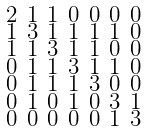<formula> <loc_0><loc_0><loc_500><loc_500>\begin{smallmatrix} 2 & 1 & 1 & 0 & 0 & 0 & 0 \\ 1 & 3 & 1 & 1 & 1 & 1 & 0 \\ 1 & 1 & 3 & 1 & 1 & 0 & 0 \\ 0 & 1 & 1 & 3 & 1 & 1 & 0 \\ 0 & 1 & 1 & 1 & 3 & 0 & 0 \\ 0 & 1 & 0 & 1 & 0 & 3 & 1 \\ 0 & 0 & 0 & 0 & 0 & 1 & 3 \end{smallmatrix}</formula> 